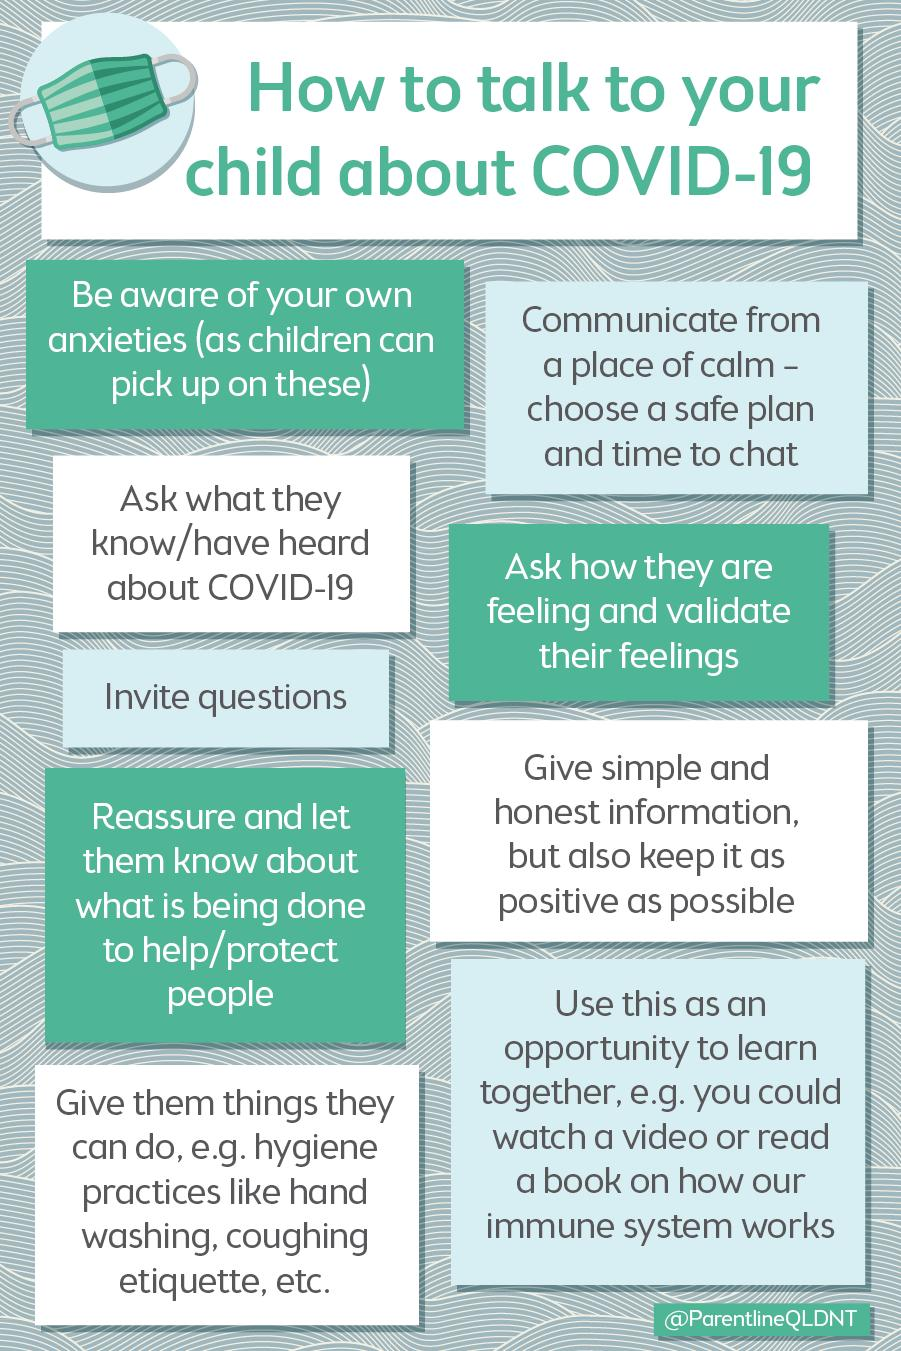Specify some key components in this picture. The number of points discussed is nine. 